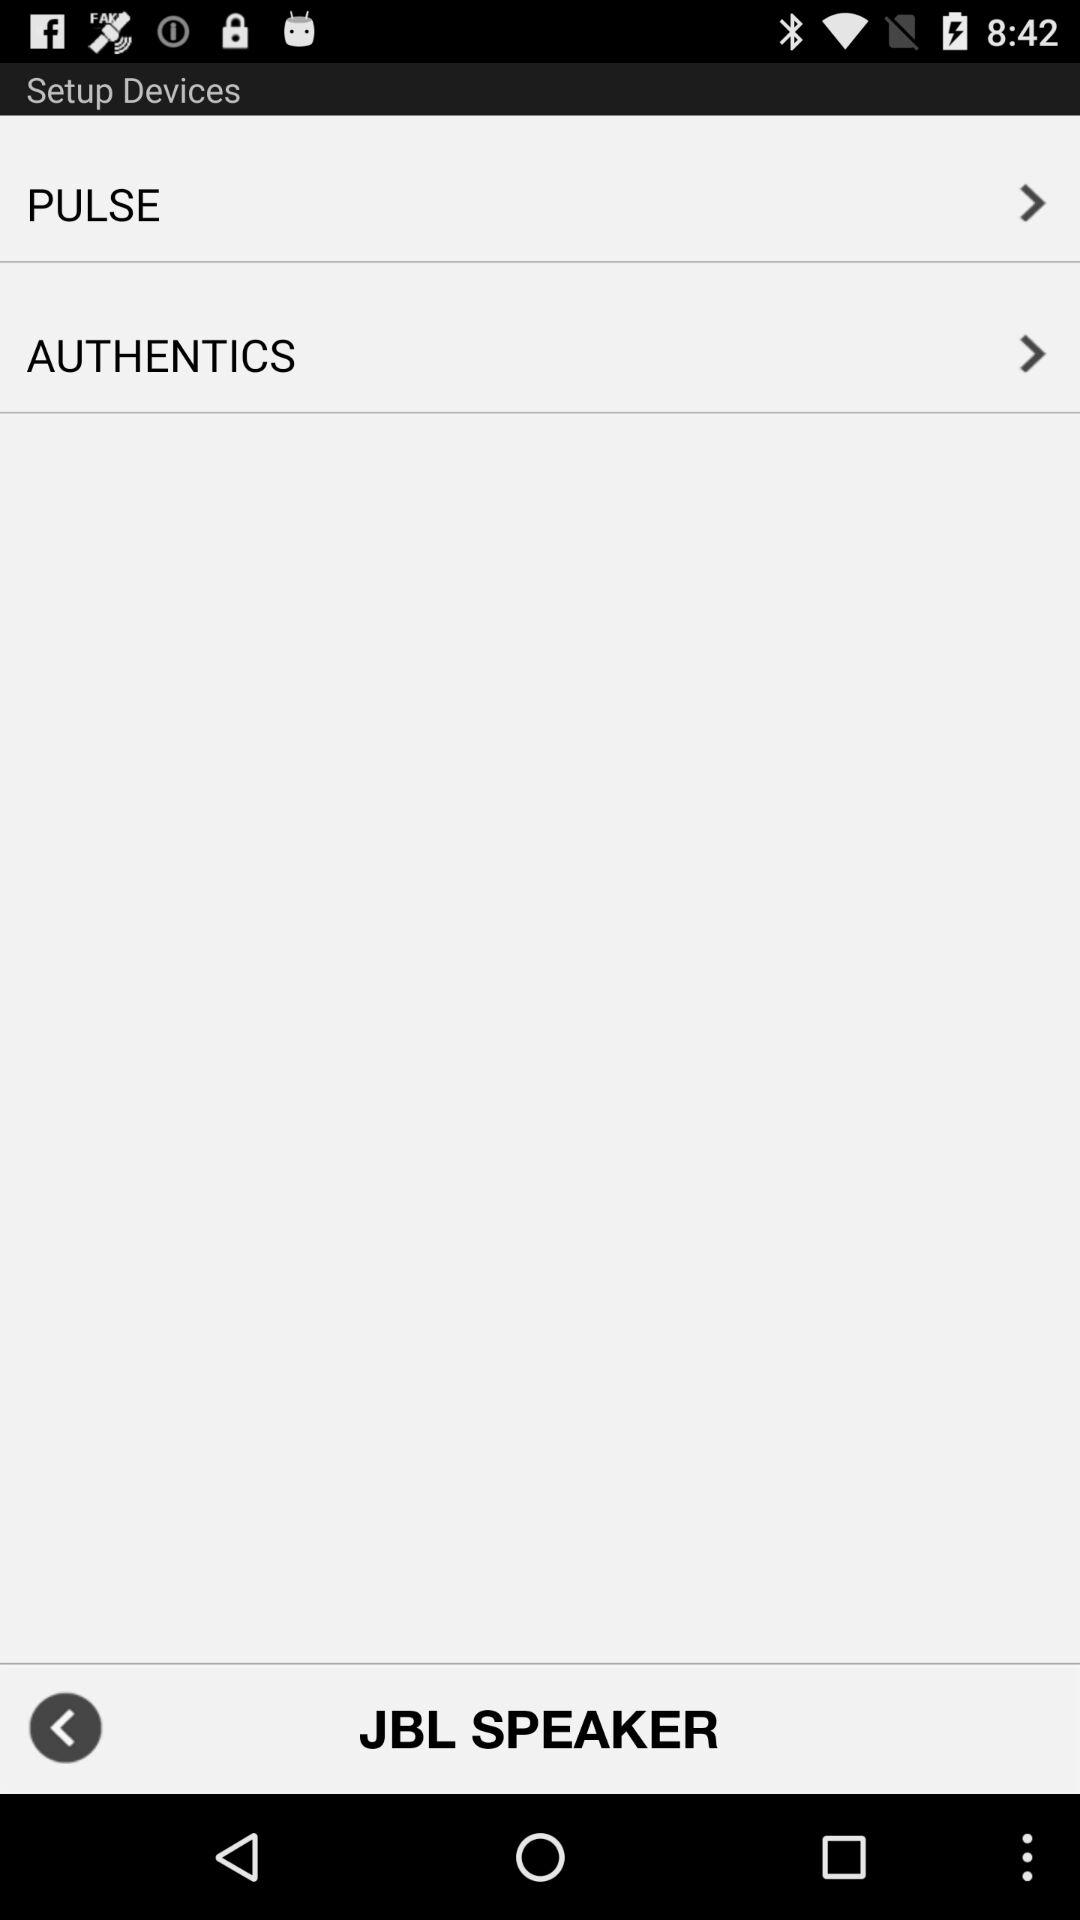What is the speaker name? The speaker name is "JBL SPEAKER". 